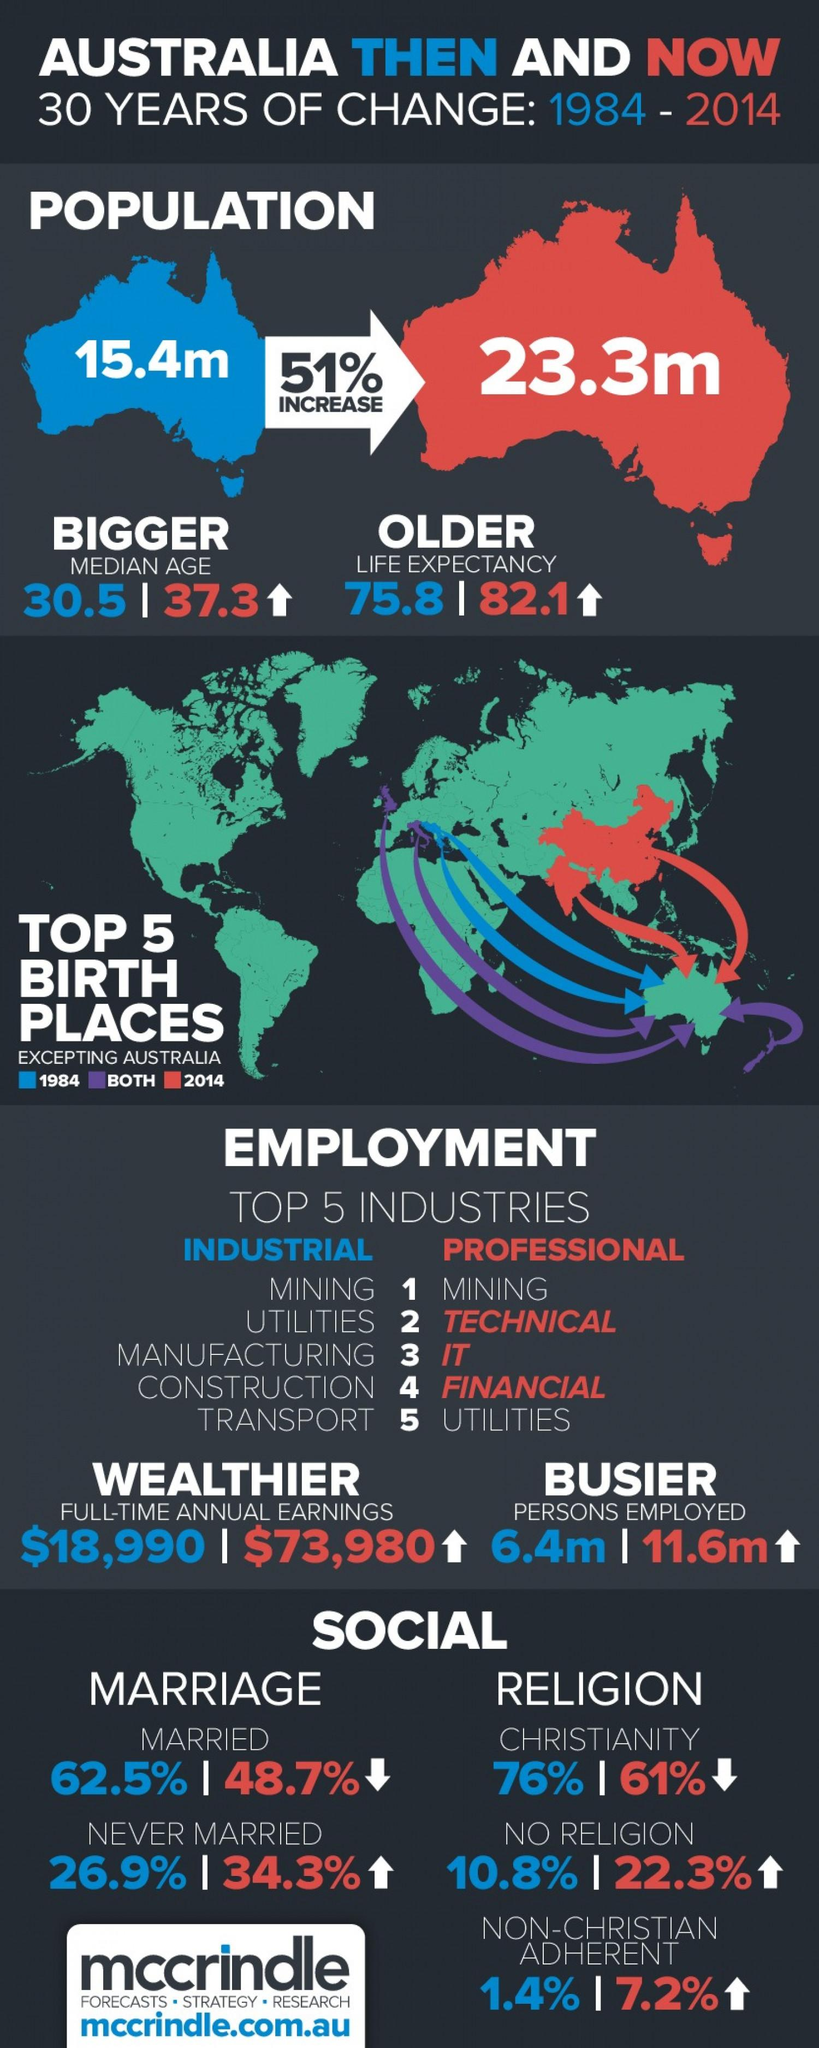Outline some significant characteristics in this image. In the year 2014, there were approximately 5.2 more Australians employed compared to 1984. In the year 2014, 22.3% of Australians followed no religion. As of 2014, the population of Australia was approximately 23.3 million people. In the year 2014, 34.3% of Australians had never been married. The median age between the year 1984 and 2014 was 6.8 years. 